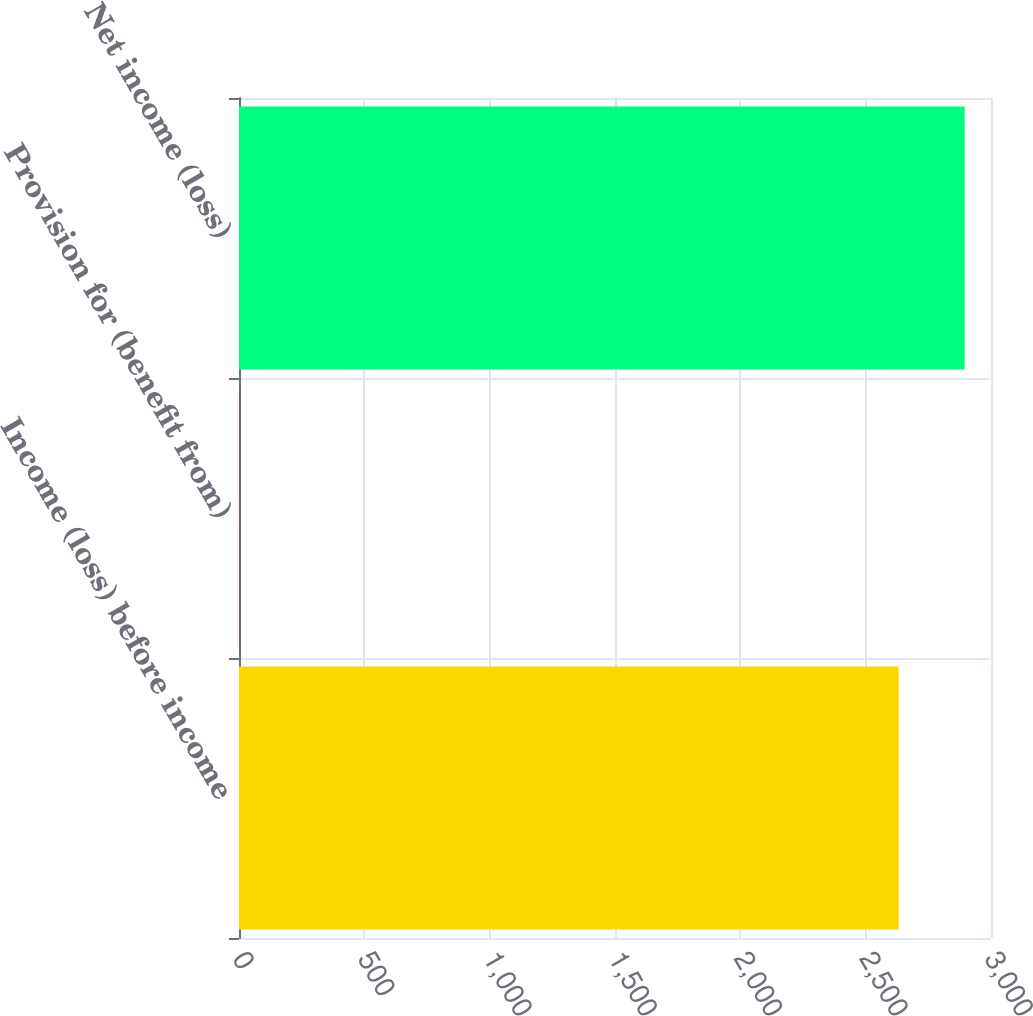Convert chart. <chart><loc_0><loc_0><loc_500><loc_500><bar_chart><fcel>Income (loss) before income<fcel>Provision for (benefit from)<fcel>Net income (loss)<nl><fcel>2631.8<fcel>1.8<fcel>2894.98<nl></chart> 